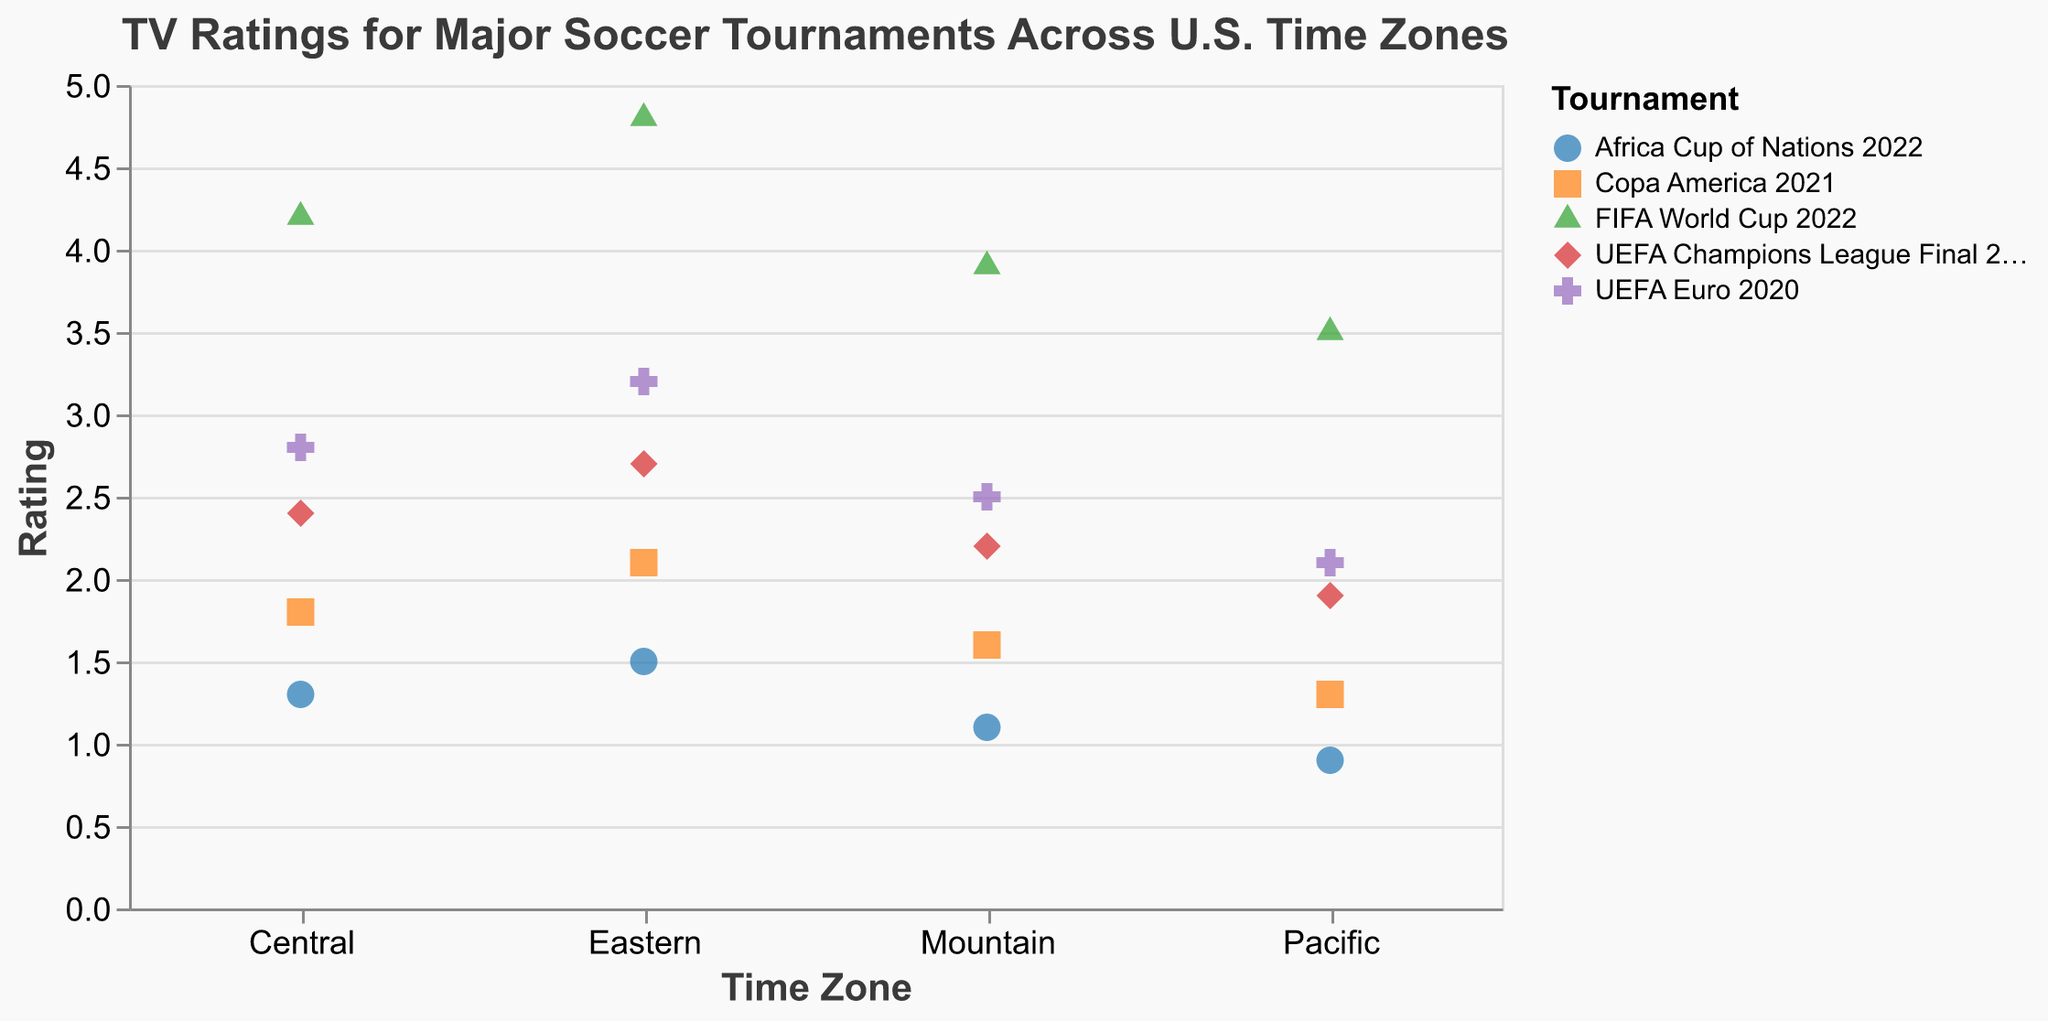What's the title of the plot? The title is displayed at the top of the plot and reads "TV Ratings for Major Soccer Tournaments Across U.S. Time Zones".
Answer: TV Ratings for Major Soccer Tournaments Across U.S. Time Zones Which tournament has the highest TV rating? By looking at the vertical position of the markers, the FIFA World Cup 2022 in the Eastern time zone has the highest rating of 4.8.
Answer: FIFA World Cup 2022 Which time zone has generally lower TV ratings across all tournaments? By scanning the plot, the Pacific time zone consistently has the lowest ratings for all tournaments.
Answer: Pacific What's the TV rating for the UEFA Champions League Final 2022 in the Central time zone? Locate the Central time zone on the x-axis and identify the marker for the UEFA Champions League Final 2022, which has a rating of 2.4.
Answer: 2.4 Rank the tournaments in the Eastern time zone from highest to lowest rating. Look at the Eastern time zone column and compare the ratings for each tournament: FIFA World Cup 2022 (4.8), UEFA Euro 2020 (3.2), UEFA Champions League Final 2022 (2.7), Copa America 2021 (2.1), Africa Cup of Nations 2022 (1.5).
Answer: FIFA World Cup 2022, UEFA Euro 2020, UEFA Champions League Final 2022, Copa America 2021, Africa Cup of Nations 2022 How much higher is the rating of the FIFA World Cup 2022 in the Central time zone compared to the UEFA Euro 2020 in the same zone? Subtract the rating of UEFA Euro 2020 (2.8) from the rating of FIFA World Cup 2022 (4.2) in the Central time zone. The difference is 4.2 - 2.8 = 1.4.
Answer: 1.4 What is the average TV rating for the Africa Cup of Nations 2022 across all time zones? Add the ratings for Africa Cup of Nations 2022 across all time zones and divide by the number of zones: (1.5 + 1.3 + 1.1 + 0.9)/4 = 1.2.
Answer: 1.2 What is the trend of TV ratings from Eastern to Pacific time zones for the UEFA Euro 2020? Look at the markers for the UEFA Euro 2020 from Eastern (3.2), Central (2.8), Mountain (2.5), to Pacific (2.1). The trend shows a consistent decrease in ratings.
Answer: Decreasing Which tournament has a higher TV rating in the Pacific time zone, the UEFA Champions League Final 2022 or the Africa Cup of Nations 2022? Compare the TV ratings for the tournaments in the Pacific time zone: UEFA Champions League Final 2022 (1.9) and Africa Cup of Nations 2022 (0.9). The UEFA Champions League Final 2022 has the higher rating.
Answer: UEFA Champions League Final 2022 